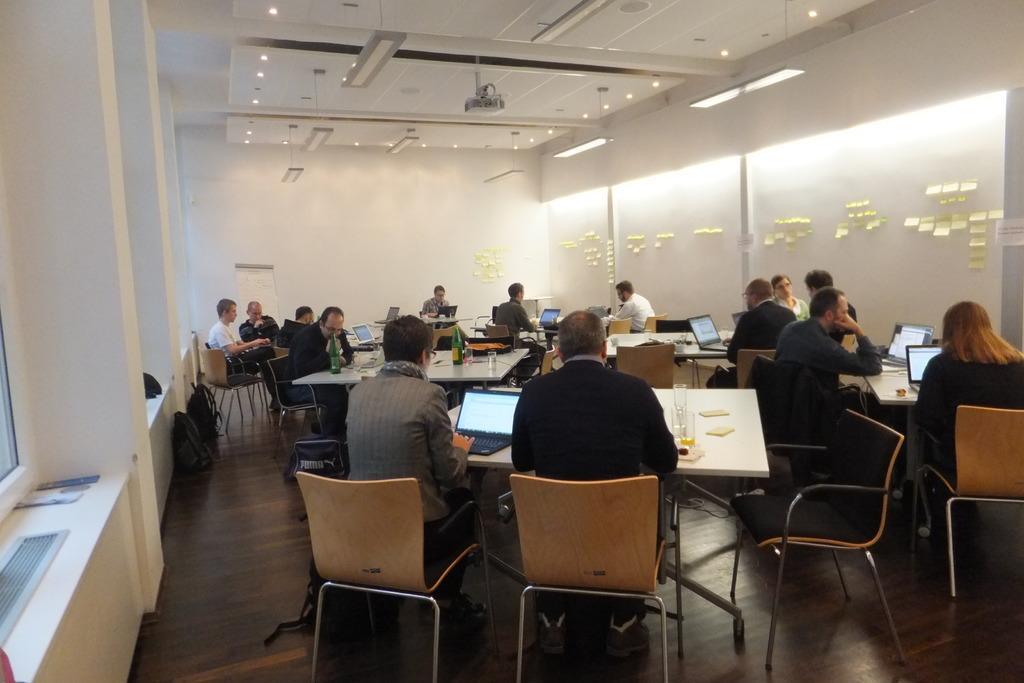Could you give a brief overview of what you see in this image? This image is clicked in a room. There are lights on the top and there are small papers pasted on the wall. There are so many tables and chairs. People are sitting on chairs near the tables. On the tables there are glasses, laptops, bottles. There are windows on the left side. 